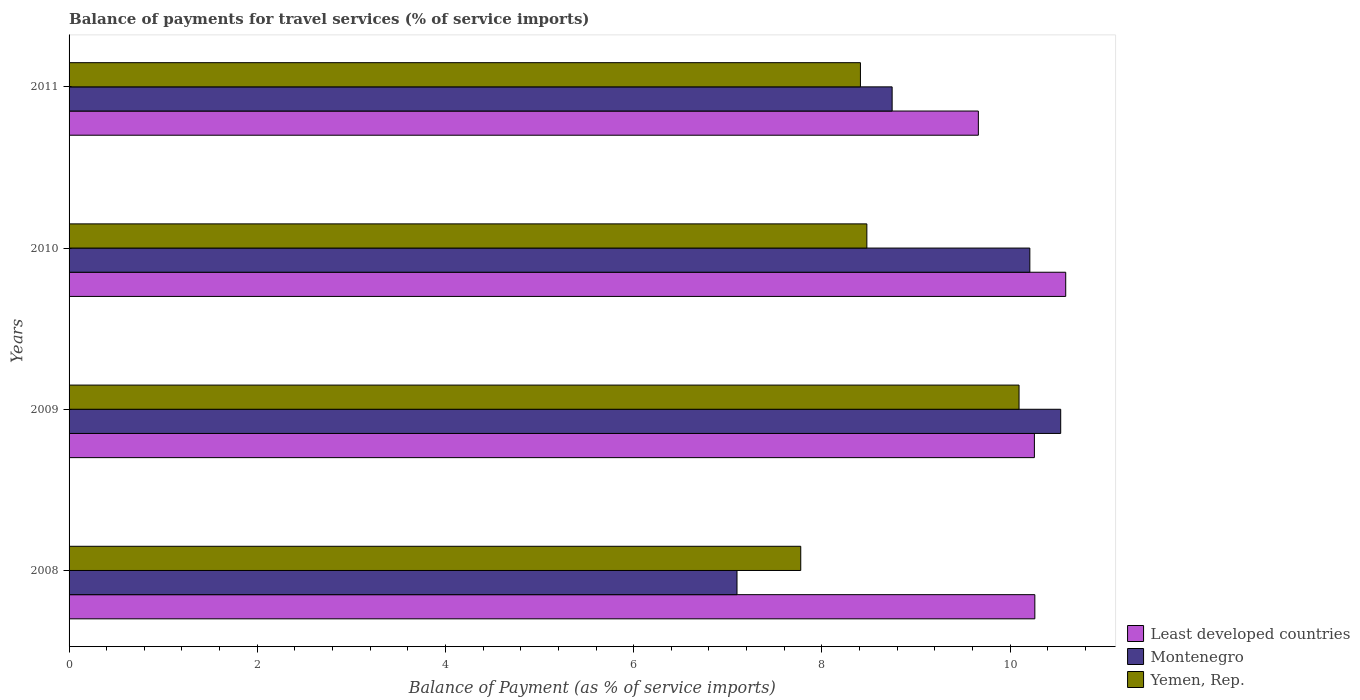How many different coloured bars are there?
Offer a terse response. 3. How many groups of bars are there?
Keep it short and to the point. 4. Are the number of bars on each tick of the Y-axis equal?
Your answer should be very brief. Yes. How many bars are there on the 1st tick from the bottom?
Provide a short and direct response. 3. What is the label of the 1st group of bars from the top?
Give a very brief answer. 2011. In how many cases, is the number of bars for a given year not equal to the number of legend labels?
Offer a very short reply. 0. What is the balance of payments for travel services in Montenegro in 2010?
Your response must be concise. 10.21. Across all years, what is the maximum balance of payments for travel services in Yemen, Rep.?
Keep it short and to the point. 10.1. Across all years, what is the minimum balance of payments for travel services in Montenegro?
Provide a short and direct response. 7.1. In which year was the balance of payments for travel services in Yemen, Rep. maximum?
Your answer should be very brief. 2009. What is the total balance of payments for travel services in Least developed countries in the graph?
Keep it short and to the point. 40.78. What is the difference between the balance of payments for travel services in Yemen, Rep. in 2008 and that in 2011?
Make the answer very short. -0.63. What is the difference between the balance of payments for travel services in Least developed countries in 2010 and the balance of payments for travel services in Montenegro in 2011?
Your response must be concise. 1.84. What is the average balance of payments for travel services in Least developed countries per year?
Offer a terse response. 10.19. In the year 2008, what is the difference between the balance of payments for travel services in Least developed countries and balance of payments for travel services in Montenegro?
Offer a terse response. 3.17. What is the ratio of the balance of payments for travel services in Yemen, Rep. in 2009 to that in 2010?
Your answer should be compact. 1.19. Is the balance of payments for travel services in Least developed countries in 2010 less than that in 2011?
Your response must be concise. No. Is the difference between the balance of payments for travel services in Least developed countries in 2010 and 2011 greater than the difference between the balance of payments for travel services in Montenegro in 2010 and 2011?
Provide a succinct answer. No. What is the difference between the highest and the second highest balance of payments for travel services in Least developed countries?
Your answer should be compact. 0.33. What is the difference between the highest and the lowest balance of payments for travel services in Least developed countries?
Make the answer very short. 0.93. Is the sum of the balance of payments for travel services in Yemen, Rep. in 2008 and 2010 greater than the maximum balance of payments for travel services in Least developed countries across all years?
Your answer should be compact. Yes. What does the 2nd bar from the top in 2011 represents?
Offer a very short reply. Montenegro. What does the 1st bar from the bottom in 2009 represents?
Offer a very short reply. Least developed countries. Is it the case that in every year, the sum of the balance of payments for travel services in Least developed countries and balance of payments for travel services in Yemen, Rep. is greater than the balance of payments for travel services in Montenegro?
Give a very brief answer. Yes. How many bars are there?
Ensure brevity in your answer.  12. Are all the bars in the graph horizontal?
Your answer should be compact. Yes. Are the values on the major ticks of X-axis written in scientific E-notation?
Offer a terse response. No. Does the graph contain grids?
Your response must be concise. No. Where does the legend appear in the graph?
Provide a succinct answer. Bottom right. What is the title of the graph?
Keep it short and to the point. Balance of payments for travel services (% of service imports). What is the label or title of the X-axis?
Your answer should be compact. Balance of Payment (as % of service imports). What is the label or title of the Y-axis?
Provide a short and direct response. Years. What is the Balance of Payment (as % of service imports) of Least developed countries in 2008?
Your answer should be very brief. 10.26. What is the Balance of Payment (as % of service imports) in Montenegro in 2008?
Ensure brevity in your answer.  7.1. What is the Balance of Payment (as % of service imports) in Yemen, Rep. in 2008?
Keep it short and to the point. 7.78. What is the Balance of Payment (as % of service imports) of Least developed countries in 2009?
Offer a terse response. 10.26. What is the Balance of Payment (as % of service imports) in Montenegro in 2009?
Your answer should be compact. 10.54. What is the Balance of Payment (as % of service imports) in Yemen, Rep. in 2009?
Give a very brief answer. 10.1. What is the Balance of Payment (as % of service imports) in Least developed countries in 2010?
Offer a very short reply. 10.59. What is the Balance of Payment (as % of service imports) in Montenegro in 2010?
Offer a very short reply. 10.21. What is the Balance of Payment (as % of service imports) of Yemen, Rep. in 2010?
Offer a terse response. 8.48. What is the Balance of Payment (as % of service imports) of Least developed countries in 2011?
Offer a terse response. 9.66. What is the Balance of Payment (as % of service imports) in Montenegro in 2011?
Provide a succinct answer. 8.75. What is the Balance of Payment (as % of service imports) in Yemen, Rep. in 2011?
Keep it short and to the point. 8.41. Across all years, what is the maximum Balance of Payment (as % of service imports) of Least developed countries?
Your answer should be very brief. 10.59. Across all years, what is the maximum Balance of Payment (as % of service imports) in Montenegro?
Your answer should be compact. 10.54. Across all years, what is the maximum Balance of Payment (as % of service imports) of Yemen, Rep.?
Your response must be concise. 10.1. Across all years, what is the minimum Balance of Payment (as % of service imports) in Least developed countries?
Ensure brevity in your answer.  9.66. Across all years, what is the minimum Balance of Payment (as % of service imports) in Montenegro?
Offer a terse response. 7.1. Across all years, what is the minimum Balance of Payment (as % of service imports) of Yemen, Rep.?
Keep it short and to the point. 7.78. What is the total Balance of Payment (as % of service imports) in Least developed countries in the graph?
Offer a terse response. 40.78. What is the total Balance of Payment (as % of service imports) in Montenegro in the graph?
Offer a terse response. 36.59. What is the total Balance of Payment (as % of service imports) in Yemen, Rep. in the graph?
Offer a very short reply. 34.76. What is the difference between the Balance of Payment (as % of service imports) in Least developed countries in 2008 and that in 2009?
Your answer should be very brief. 0. What is the difference between the Balance of Payment (as % of service imports) in Montenegro in 2008 and that in 2009?
Your answer should be compact. -3.44. What is the difference between the Balance of Payment (as % of service imports) in Yemen, Rep. in 2008 and that in 2009?
Ensure brevity in your answer.  -2.32. What is the difference between the Balance of Payment (as % of service imports) of Least developed countries in 2008 and that in 2010?
Provide a succinct answer. -0.33. What is the difference between the Balance of Payment (as % of service imports) in Montenegro in 2008 and that in 2010?
Make the answer very short. -3.11. What is the difference between the Balance of Payment (as % of service imports) of Yemen, Rep. in 2008 and that in 2010?
Make the answer very short. -0.7. What is the difference between the Balance of Payment (as % of service imports) of Least developed countries in 2008 and that in 2011?
Provide a short and direct response. 0.6. What is the difference between the Balance of Payment (as % of service imports) in Montenegro in 2008 and that in 2011?
Your answer should be very brief. -1.65. What is the difference between the Balance of Payment (as % of service imports) of Yemen, Rep. in 2008 and that in 2011?
Offer a terse response. -0.63. What is the difference between the Balance of Payment (as % of service imports) in Least developed countries in 2009 and that in 2010?
Give a very brief answer. -0.33. What is the difference between the Balance of Payment (as % of service imports) of Montenegro in 2009 and that in 2010?
Your response must be concise. 0.33. What is the difference between the Balance of Payment (as % of service imports) in Yemen, Rep. in 2009 and that in 2010?
Provide a short and direct response. 1.62. What is the difference between the Balance of Payment (as % of service imports) of Least developed countries in 2009 and that in 2011?
Provide a succinct answer. 0.6. What is the difference between the Balance of Payment (as % of service imports) in Montenegro in 2009 and that in 2011?
Your answer should be very brief. 1.79. What is the difference between the Balance of Payment (as % of service imports) of Yemen, Rep. in 2009 and that in 2011?
Your answer should be compact. 1.69. What is the difference between the Balance of Payment (as % of service imports) in Least developed countries in 2010 and that in 2011?
Ensure brevity in your answer.  0.93. What is the difference between the Balance of Payment (as % of service imports) of Montenegro in 2010 and that in 2011?
Offer a terse response. 1.46. What is the difference between the Balance of Payment (as % of service imports) in Yemen, Rep. in 2010 and that in 2011?
Make the answer very short. 0.07. What is the difference between the Balance of Payment (as % of service imports) in Least developed countries in 2008 and the Balance of Payment (as % of service imports) in Montenegro in 2009?
Offer a terse response. -0.27. What is the difference between the Balance of Payment (as % of service imports) in Least developed countries in 2008 and the Balance of Payment (as % of service imports) in Yemen, Rep. in 2009?
Offer a very short reply. 0.17. What is the difference between the Balance of Payment (as % of service imports) in Montenegro in 2008 and the Balance of Payment (as % of service imports) in Yemen, Rep. in 2009?
Offer a terse response. -3. What is the difference between the Balance of Payment (as % of service imports) of Least developed countries in 2008 and the Balance of Payment (as % of service imports) of Montenegro in 2010?
Your answer should be very brief. 0.05. What is the difference between the Balance of Payment (as % of service imports) in Least developed countries in 2008 and the Balance of Payment (as % of service imports) in Yemen, Rep. in 2010?
Ensure brevity in your answer.  1.79. What is the difference between the Balance of Payment (as % of service imports) of Montenegro in 2008 and the Balance of Payment (as % of service imports) of Yemen, Rep. in 2010?
Offer a very short reply. -1.38. What is the difference between the Balance of Payment (as % of service imports) of Least developed countries in 2008 and the Balance of Payment (as % of service imports) of Montenegro in 2011?
Make the answer very short. 1.52. What is the difference between the Balance of Payment (as % of service imports) in Least developed countries in 2008 and the Balance of Payment (as % of service imports) in Yemen, Rep. in 2011?
Your response must be concise. 1.85. What is the difference between the Balance of Payment (as % of service imports) in Montenegro in 2008 and the Balance of Payment (as % of service imports) in Yemen, Rep. in 2011?
Offer a terse response. -1.31. What is the difference between the Balance of Payment (as % of service imports) of Least developed countries in 2009 and the Balance of Payment (as % of service imports) of Montenegro in 2010?
Your response must be concise. 0.05. What is the difference between the Balance of Payment (as % of service imports) of Least developed countries in 2009 and the Balance of Payment (as % of service imports) of Yemen, Rep. in 2010?
Your response must be concise. 1.78. What is the difference between the Balance of Payment (as % of service imports) of Montenegro in 2009 and the Balance of Payment (as % of service imports) of Yemen, Rep. in 2010?
Provide a short and direct response. 2.06. What is the difference between the Balance of Payment (as % of service imports) of Least developed countries in 2009 and the Balance of Payment (as % of service imports) of Montenegro in 2011?
Keep it short and to the point. 1.51. What is the difference between the Balance of Payment (as % of service imports) in Least developed countries in 2009 and the Balance of Payment (as % of service imports) in Yemen, Rep. in 2011?
Make the answer very short. 1.85. What is the difference between the Balance of Payment (as % of service imports) in Montenegro in 2009 and the Balance of Payment (as % of service imports) in Yemen, Rep. in 2011?
Provide a succinct answer. 2.13. What is the difference between the Balance of Payment (as % of service imports) of Least developed countries in 2010 and the Balance of Payment (as % of service imports) of Montenegro in 2011?
Offer a very short reply. 1.84. What is the difference between the Balance of Payment (as % of service imports) in Least developed countries in 2010 and the Balance of Payment (as % of service imports) in Yemen, Rep. in 2011?
Make the answer very short. 2.18. What is the difference between the Balance of Payment (as % of service imports) of Montenegro in 2010 and the Balance of Payment (as % of service imports) of Yemen, Rep. in 2011?
Your response must be concise. 1.8. What is the average Balance of Payment (as % of service imports) in Least developed countries per year?
Ensure brevity in your answer.  10.19. What is the average Balance of Payment (as % of service imports) of Montenegro per year?
Ensure brevity in your answer.  9.15. What is the average Balance of Payment (as % of service imports) of Yemen, Rep. per year?
Offer a very short reply. 8.69. In the year 2008, what is the difference between the Balance of Payment (as % of service imports) in Least developed countries and Balance of Payment (as % of service imports) in Montenegro?
Make the answer very short. 3.17. In the year 2008, what is the difference between the Balance of Payment (as % of service imports) in Least developed countries and Balance of Payment (as % of service imports) in Yemen, Rep.?
Keep it short and to the point. 2.49. In the year 2008, what is the difference between the Balance of Payment (as % of service imports) of Montenegro and Balance of Payment (as % of service imports) of Yemen, Rep.?
Ensure brevity in your answer.  -0.68. In the year 2009, what is the difference between the Balance of Payment (as % of service imports) in Least developed countries and Balance of Payment (as % of service imports) in Montenegro?
Provide a short and direct response. -0.28. In the year 2009, what is the difference between the Balance of Payment (as % of service imports) of Least developed countries and Balance of Payment (as % of service imports) of Yemen, Rep.?
Ensure brevity in your answer.  0.16. In the year 2009, what is the difference between the Balance of Payment (as % of service imports) in Montenegro and Balance of Payment (as % of service imports) in Yemen, Rep.?
Your answer should be very brief. 0.44. In the year 2010, what is the difference between the Balance of Payment (as % of service imports) in Least developed countries and Balance of Payment (as % of service imports) in Montenegro?
Provide a short and direct response. 0.38. In the year 2010, what is the difference between the Balance of Payment (as % of service imports) of Least developed countries and Balance of Payment (as % of service imports) of Yemen, Rep.?
Ensure brevity in your answer.  2.11. In the year 2010, what is the difference between the Balance of Payment (as % of service imports) in Montenegro and Balance of Payment (as % of service imports) in Yemen, Rep.?
Offer a very short reply. 1.73. In the year 2011, what is the difference between the Balance of Payment (as % of service imports) in Least developed countries and Balance of Payment (as % of service imports) in Montenegro?
Provide a succinct answer. 0.92. In the year 2011, what is the difference between the Balance of Payment (as % of service imports) in Least developed countries and Balance of Payment (as % of service imports) in Yemen, Rep.?
Your answer should be compact. 1.25. In the year 2011, what is the difference between the Balance of Payment (as % of service imports) in Montenegro and Balance of Payment (as % of service imports) in Yemen, Rep.?
Your answer should be compact. 0.34. What is the ratio of the Balance of Payment (as % of service imports) of Least developed countries in 2008 to that in 2009?
Keep it short and to the point. 1. What is the ratio of the Balance of Payment (as % of service imports) of Montenegro in 2008 to that in 2009?
Ensure brevity in your answer.  0.67. What is the ratio of the Balance of Payment (as % of service imports) in Yemen, Rep. in 2008 to that in 2009?
Provide a short and direct response. 0.77. What is the ratio of the Balance of Payment (as % of service imports) of Montenegro in 2008 to that in 2010?
Your answer should be compact. 0.7. What is the ratio of the Balance of Payment (as % of service imports) in Yemen, Rep. in 2008 to that in 2010?
Make the answer very short. 0.92. What is the ratio of the Balance of Payment (as % of service imports) of Least developed countries in 2008 to that in 2011?
Make the answer very short. 1.06. What is the ratio of the Balance of Payment (as % of service imports) in Montenegro in 2008 to that in 2011?
Provide a succinct answer. 0.81. What is the ratio of the Balance of Payment (as % of service imports) of Yemen, Rep. in 2008 to that in 2011?
Your answer should be compact. 0.92. What is the ratio of the Balance of Payment (as % of service imports) in Least developed countries in 2009 to that in 2010?
Your response must be concise. 0.97. What is the ratio of the Balance of Payment (as % of service imports) in Montenegro in 2009 to that in 2010?
Make the answer very short. 1.03. What is the ratio of the Balance of Payment (as % of service imports) in Yemen, Rep. in 2009 to that in 2010?
Your answer should be very brief. 1.19. What is the ratio of the Balance of Payment (as % of service imports) of Least developed countries in 2009 to that in 2011?
Offer a very short reply. 1.06. What is the ratio of the Balance of Payment (as % of service imports) in Montenegro in 2009 to that in 2011?
Offer a very short reply. 1.2. What is the ratio of the Balance of Payment (as % of service imports) in Yemen, Rep. in 2009 to that in 2011?
Your answer should be very brief. 1.2. What is the ratio of the Balance of Payment (as % of service imports) in Least developed countries in 2010 to that in 2011?
Make the answer very short. 1.1. What is the ratio of the Balance of Payment (as % of service imports) in Montenegro in 2010 to that in 2011?
Make the answer very short. 1.17. What is the ratio of the Balance of Payment (as % of service imports) of Yemen, Rep. in 2010 to that in 2011?
Your answer should be compact. 1.01. What is the difference between the highest and the second highest Balance of Payment (as % of service imports) of Least developed countries?
Offer a very short reply. 0.33. What is the difference between the highest and the second highest Balance of Payment (as % of service imports) of Montenegro?
Your response must be concise. 0.33. What is the difference between the highest and the second highest Balance of Payment (as % of service imports) in Yemen, Rep.?
Your answer should be very brief. 1.62. What is the difference between the highest and the lowest Balance of Payment (as % of service imports) in Least developed countries?
Provide a succinct answer. 0.93. What is the difference between the highest and the lowest Balance of Payment (as % of service imports) in Montenegro?
Offer a terse response. 3.44. What is the difference between the highest and the lowest Balance of Payment (as % of service imports) of Yemen, Rep.?
Offer a very short reply. 2.32. 